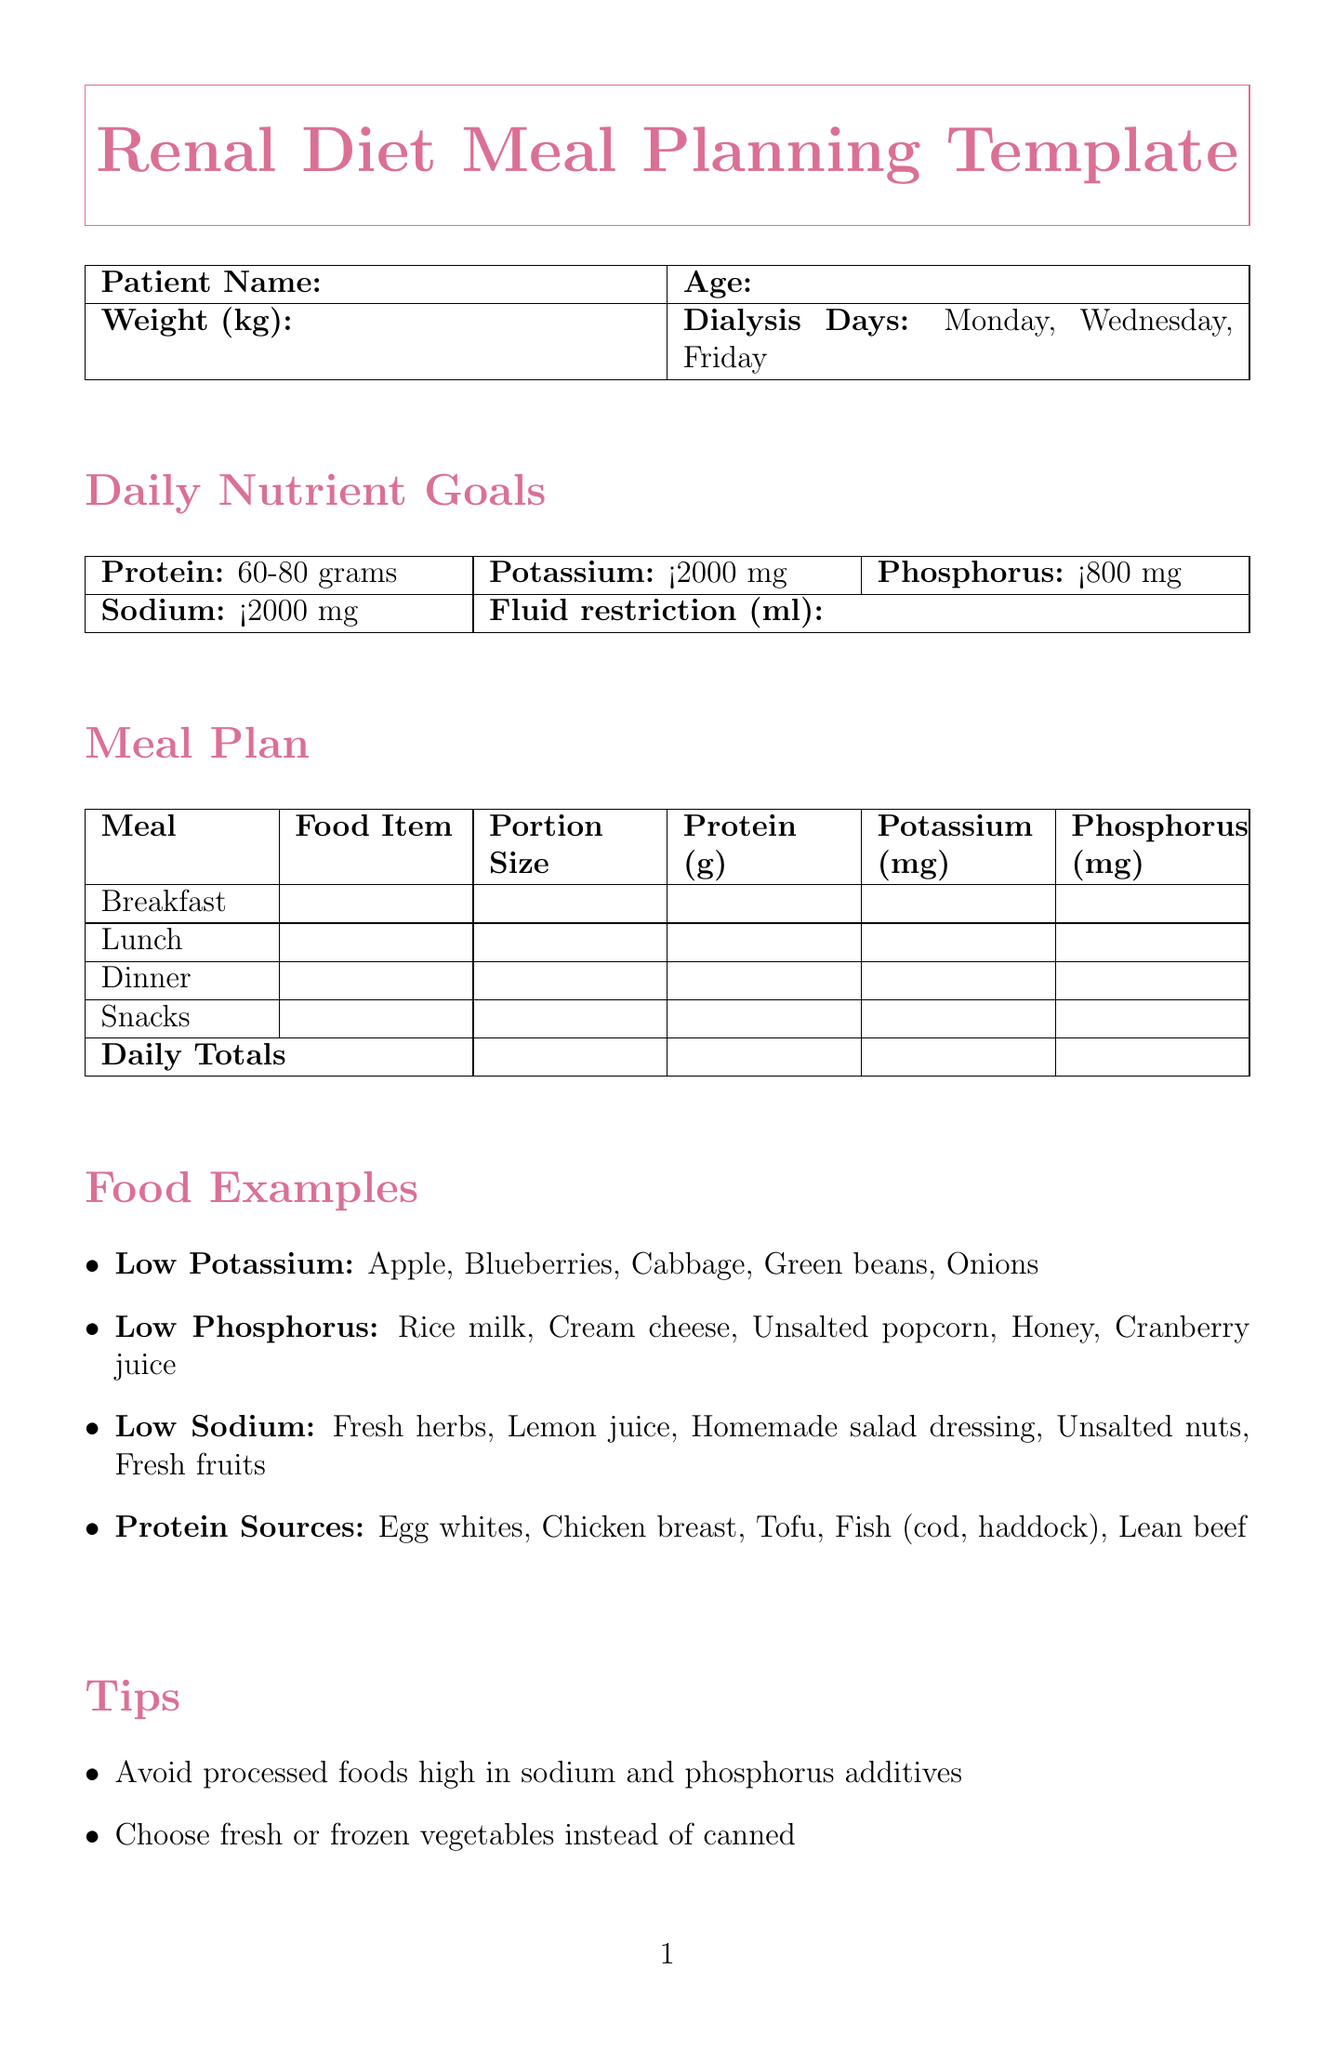What is the patient's weight? The patient’s weight is specified in the document as a customizable section under patient information.
Answer: Weight (kg) What is the recommended potassium intake? The document specifies the daily nutrient goals for potassium.
Answer: Less than 2000 mg How many dialysis days are there in a week? The document lists the days when dialysis occurs.
Answer: Three days What is one low potassium food example? The document provides examples of foods that are low in potassium.
Answer: Apple What is the total protein goal? The document outlines the daily nutrient goals specifically for protein intake.
Answer: 60-80 grams What is advised to limit due to high phosphorus content? The document lists dietary recommendations, including one specific limitation.
Answer: Dairy intake What should be used instead of salt for flavoring? The document suggests alternatives for seasoning in the dietary tips section.
Answer: Herbs and spices What is required in the fluid tracking section? The fluid tracking part of the document requests specific information to be recorded.
Answer: Daily fluid allowance How is the medication information formatted in the document? The document organizes medication reminders into a structured table format.
Answer: Medication Name, Dosage, Frequency, Take with meal? What section discusses dietary tips? The document includes a part dedicated to advising on dietary practices.
Answer: Tips 